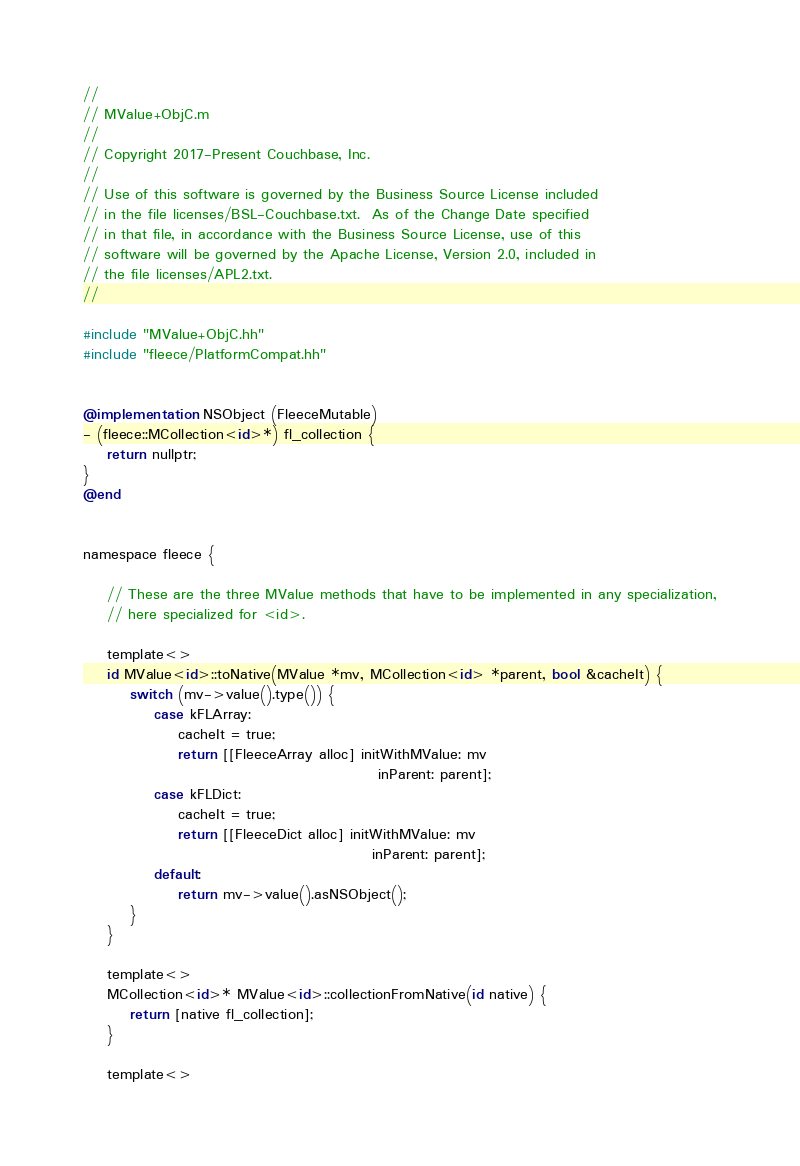Convert code to text. <code><loc_0><loc_0><loc_500><loc_500><_ObjectiveC_>//
// MValue+ObjC.m
//
// Copyright 2017-Present Couchbase, Inc.
//
// Use of this software is governed by the Business Source License included
// in the file licenses/BSL-Couchbase.txt.  As of the Change Date specified
// in that file, in accordance with the Business Source License, use of this
// software will be governed by the Apache License, Version 2.0, included in
// the file licenses/APL2.txt.
//

#include "MValue+ObjC.hh"
#include "fleece/PlatformCompat.hh"


@implementation NSObject (FleeceMutable)
- (fleece::MCollection<id>*) fl_collection {
    return nullptr;
}
@end


namespace fleece {

    // These are the three MValue methods that have to be implemented in any specialization,
    // here specialized for <id>.

    template<>
    id MValue<id>::toNative(MValue *mv, MCollection<id> *parent, bool &cacheIt) {
        switch (mv->value().type()) {
            case kFLArray:
                cacheIt = true;
                return [[FleeceArray alloc] initWithMValue: mv
                                                  inParent: parent];
            case kFLDict:
                cacheIt = true;
                return [[FleeceDict alloc] initWithMValue: mv
                                                 inParent: parent];
            default:
                return mv->value().asNSObject();
        }
    }

    template<>
    MCollection<id>* MValue<id>::collectionFromNative(id native) {
        return [native fl_collection];
    }

    template<></code> 